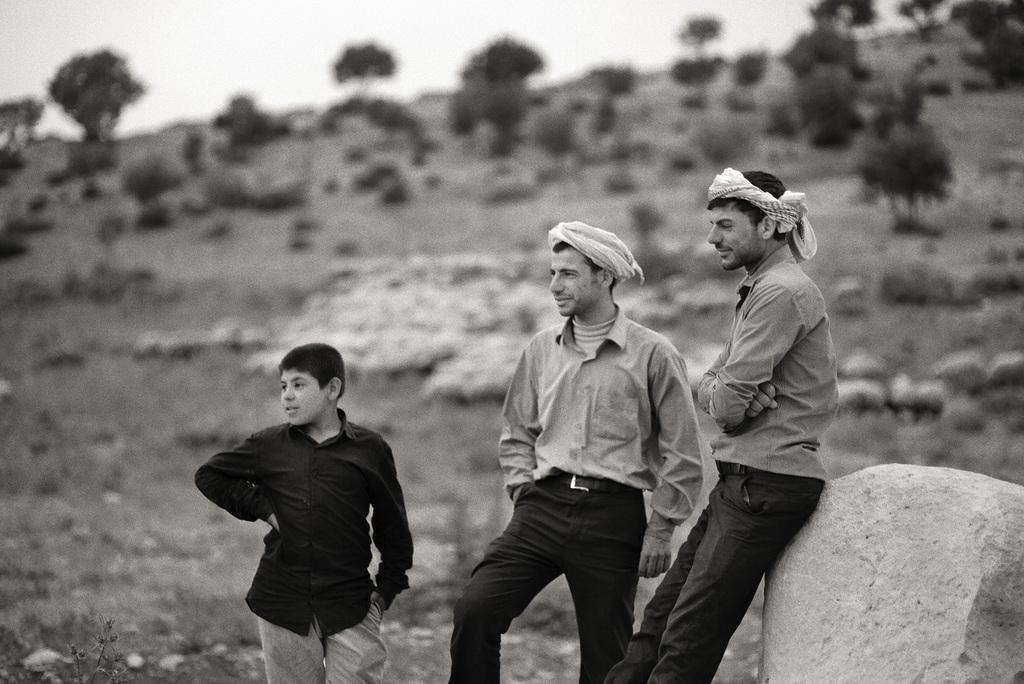What is the color scheme of the image? The image is black and white. How many people are in the image? There are three persons standing beside a rock. What can be seen in the background of the image? There are trees in the background of the image. What type of battle is taking place in the image? There is no battle present in the image; it features three persons standing beside a rock. Can you see any trains in the image? There are no trains present in the image. 